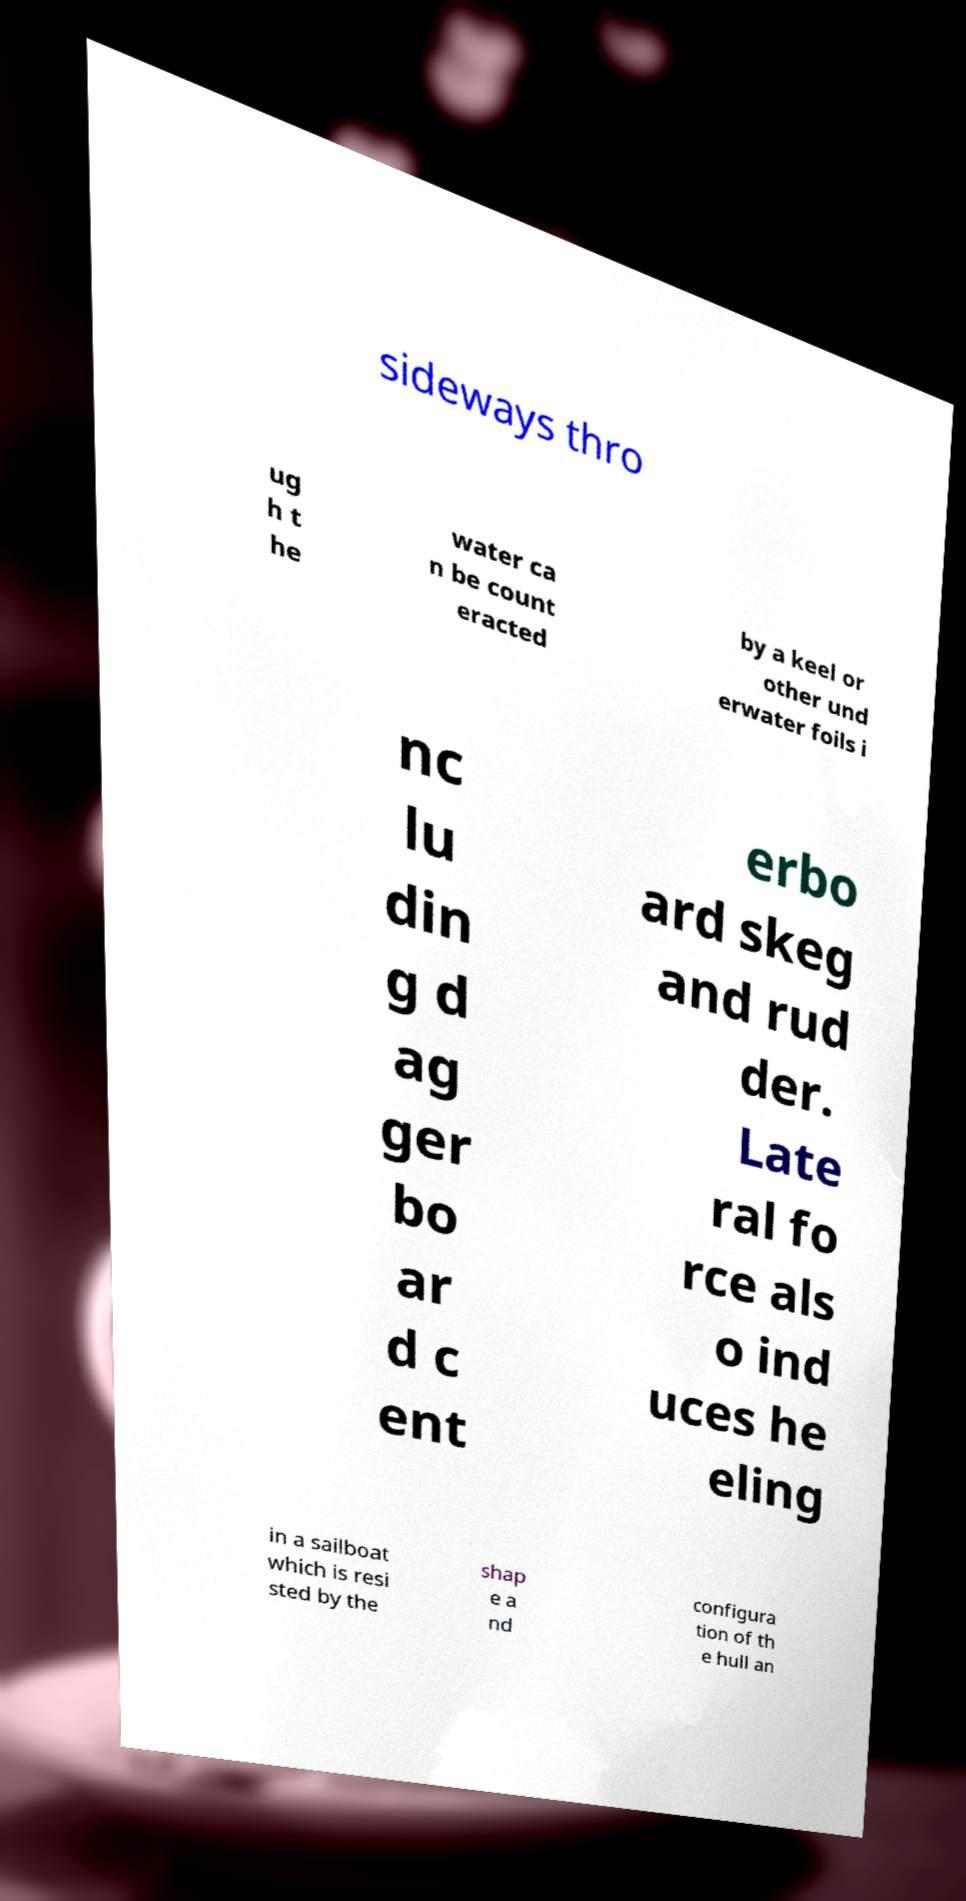Please identify and transcribe the text found in this image. sideways thro ug h t he water ca n be count eracted by a keel or other und erwater foils i nc lu din g d ag ger bo ar d c ent erbo ard skeg and rud der. Late ral fo rce als o ind uces he eling in a sailboat which is resi sted by the shap e a nd configura tion of th e hull an 